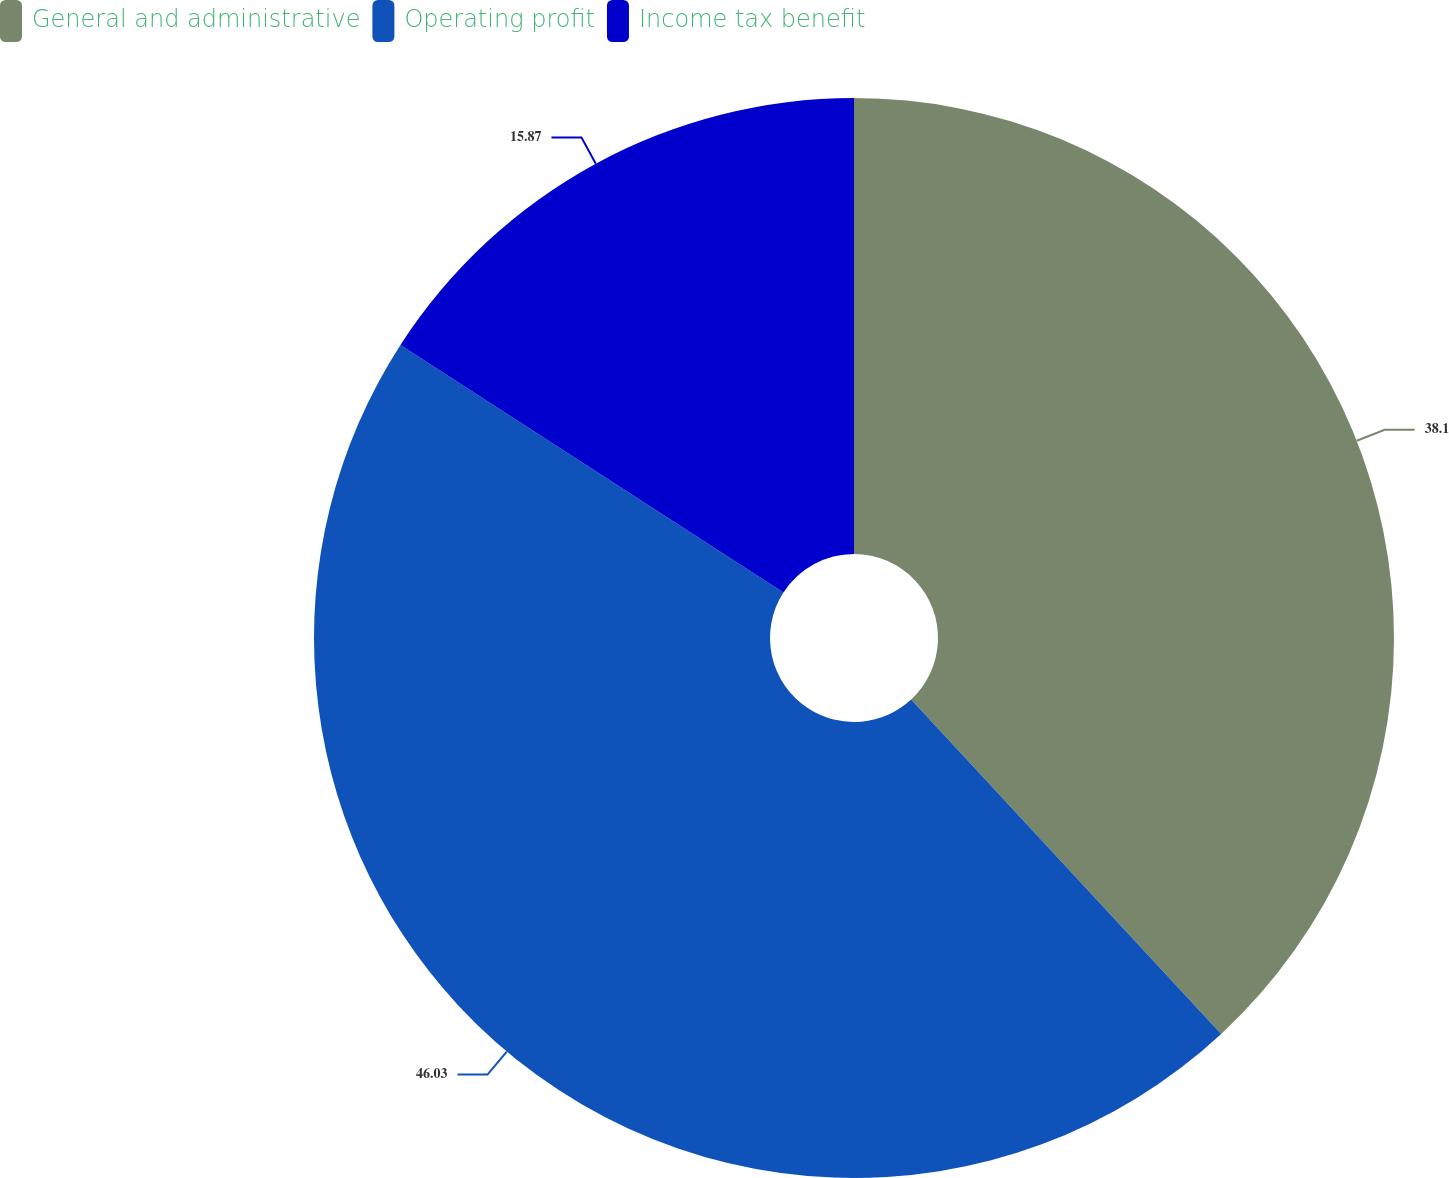Convert chart to OTSL. <chart><loc_0><loc_0><loc_500><loc_500><pie_chart><fcel>General and administrative<fcel>Operating profit<fcel>Income tax benefit<nl><fcel>38.1%<fcel>46.03%<fcel>15.87%<nl></chart> 